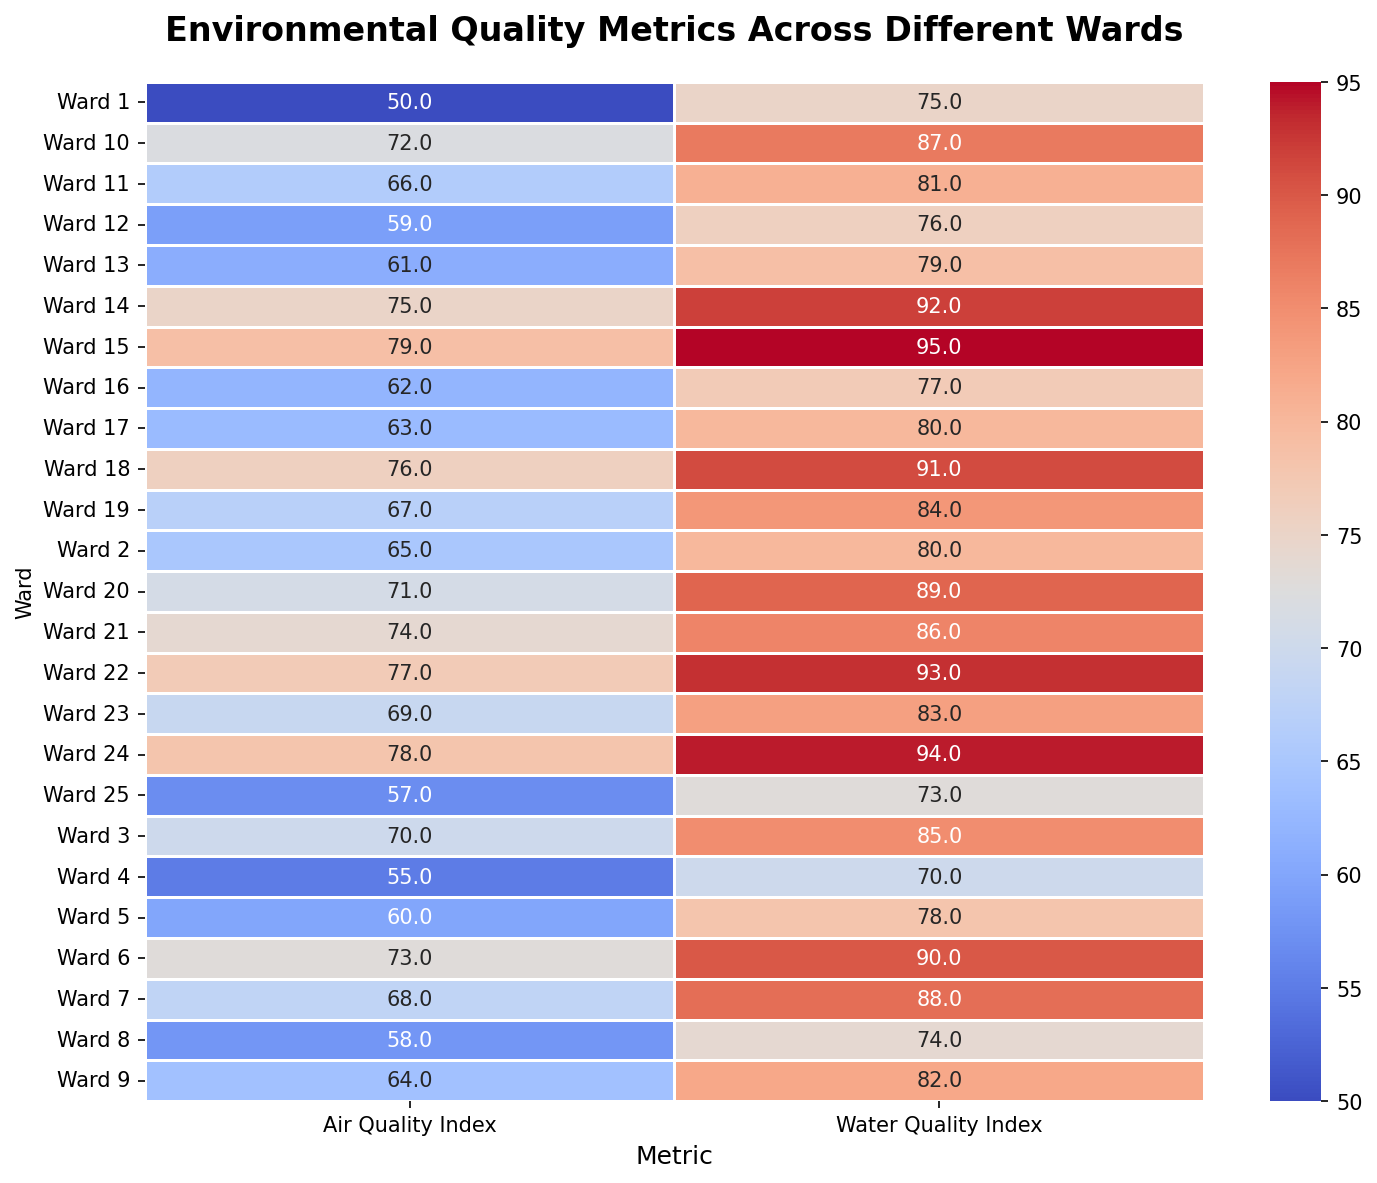What's the highest Air Quality Index value observed across all wards? By observing the heatmap, the highest value will be the darkest red color in the 'Air Quality Index' column. Find the cell with the highest numeric value.
Answer: 79 Which wards have an Air Quality Index greater than 70? Look for cells in the 'Air Quality Index' column that display a value above 70. Refer to the ward labels corresponding to these cells.
Answer: Wards 6, 10, 14, 15, 18, 21, 22, 24 Is there any ward with both Air Quality and Water Quality Index above 90? Check both 'Air Quality Index' and 'Water Quality Index' columns to identify if any ward has values greater than 90 in both columns.
Answer: No Which ward has the lowest Water Quality Index, and what is its value? Observe the cells in the 'Water Quality Index' column for the lightest blue color to find the lowest numeric value. Then, refer to the corresponding ward label.
Answer: Ward 4, 70 What is the average Air Quality Index of wards with a Water Quality Index above 85? Identify wards with a Water Quality Index above 85. Sum their Air Quality Index values, and divide by the number of such wards.
Answer: (73 + 68 + 72 + 75 + 79 + 76 + 74 + 77 + 78) / 9 = 699 / 9 = 77.67 Which ward shows the greatest difference between Air Quality and Water Quality Index? Calculate the difference for each ward by subtracting the Air Quality Index from the Water Quality Index. Then, identify the ward with the maximum difference.
Answer: Ward 15, (95 - 79 = 16) Compared to Ward 1, which ward has a better Air Quality Index and by how much? Find the Air Quality Index of Ward 1 and compare it to other wards. Determine how many wards have a higher value and indicate the highest difference in values.
Answer: Ward 15, 79 - 50 = 29 